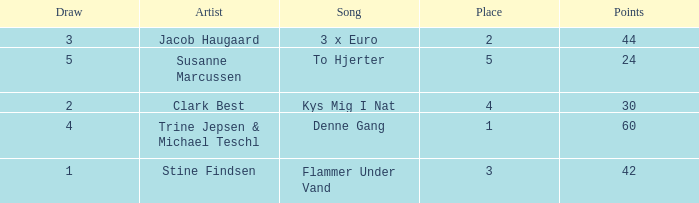Parse the table in full. {'header': ['Draw', 'Artist', 'Song', 'Place', 'Points'], 'rows': [['3', 'Jacob Haugaard', '3 x Euro', '2', '44'], ['5', 'Susanne Marcussen', 'To Hjerter', '5', '24'], ['2', 'Clark Best', 'Kys Mig I Nat', '4', '30'], ['4', 'Trine Jepsen & Michael Teschl', 'Denne Gang', '1', '60'], ['1', 'Stine Findsen', 'Flammer Under Vand', '3', '42']]} What is the lowest Draw when the Artist is Stine Findsen and the Points are larger than 42? None. 